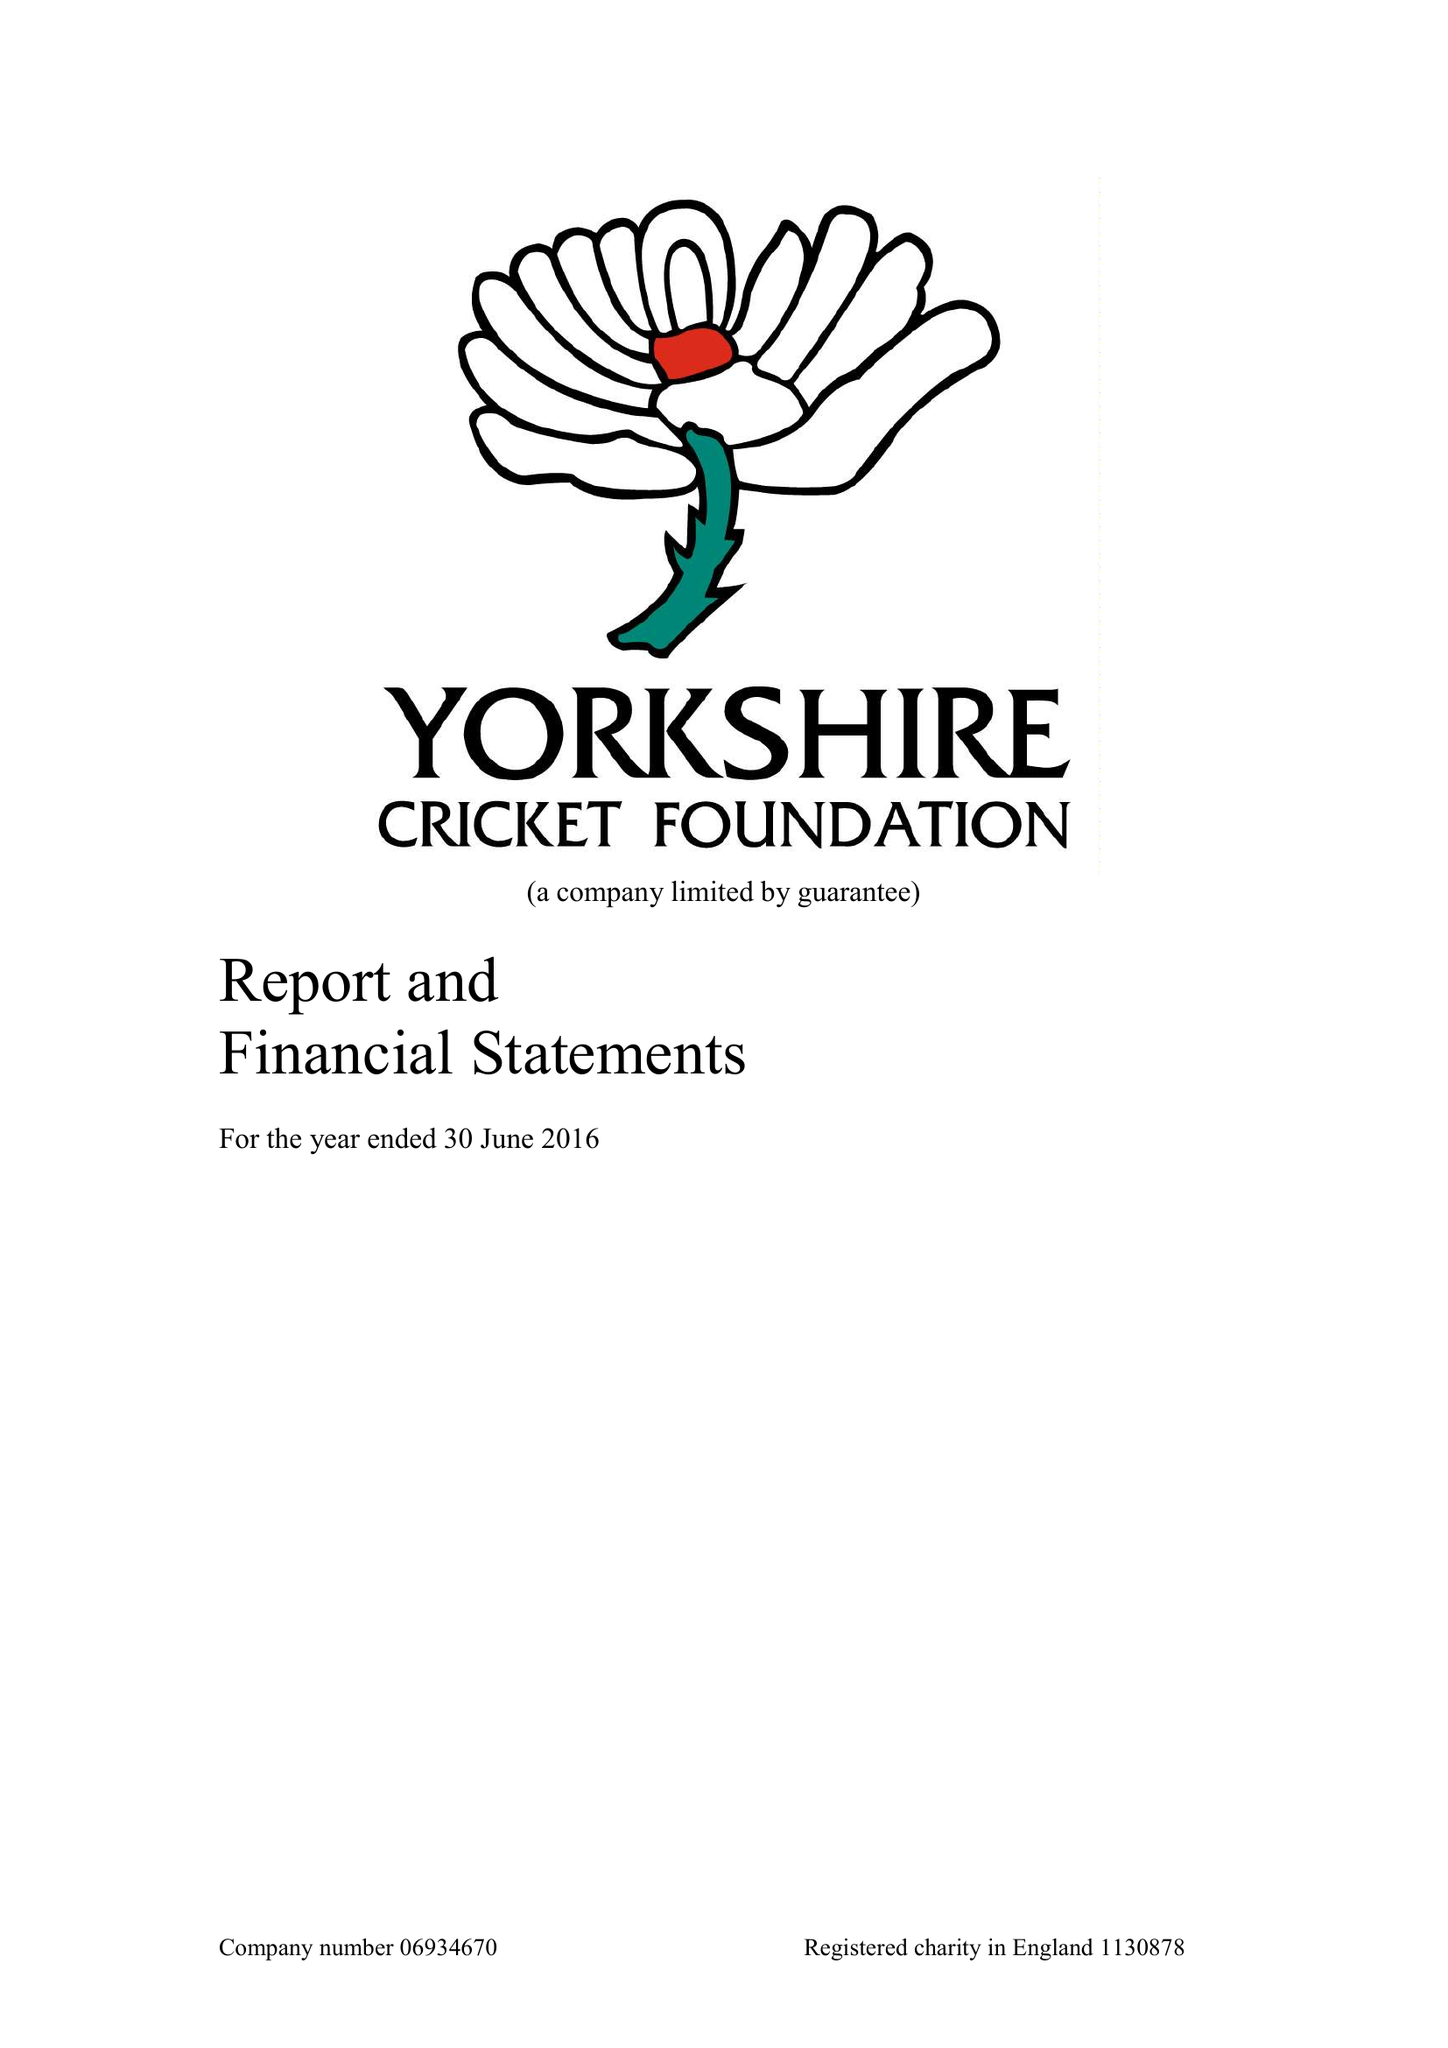What is the value for the spending_annually_in_british_pounds?
Answer the question using a single word or phrase. 286303.00 